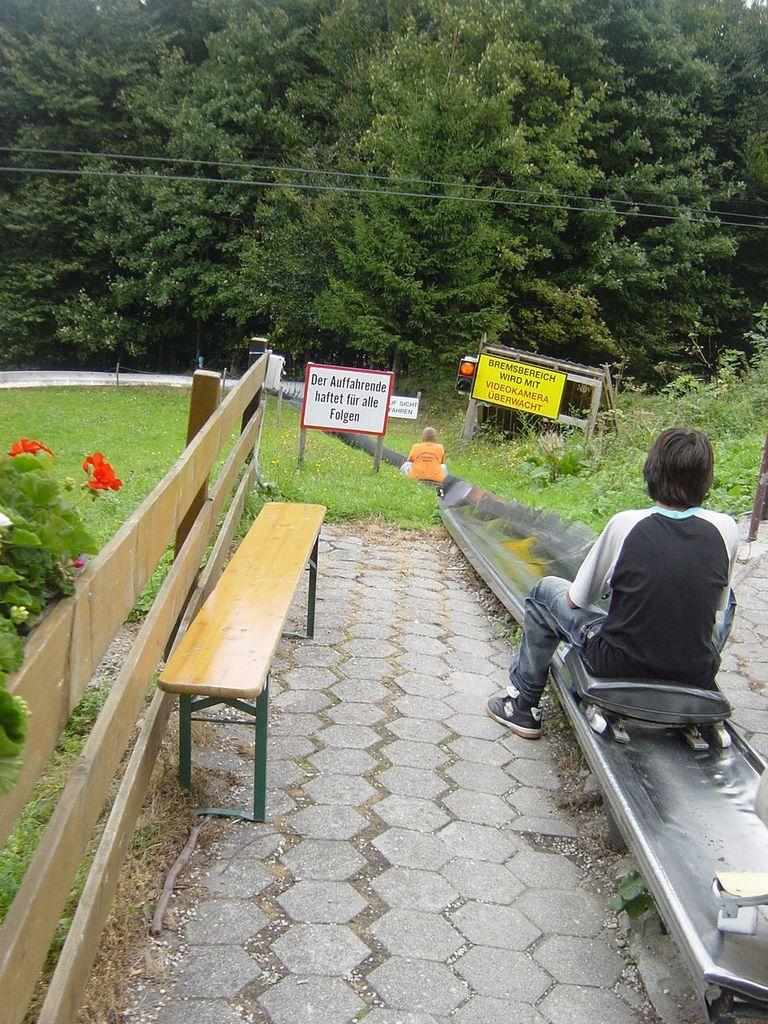Who is the main subject in the image? There is a woman in the image. What is the woman doing in the image? The woman is sitting on a skateboard. What can be seen in the background of the image? There is a bench, plants, grass, boards, and trees in the background of the image. What type of star can be seen shining above the woman in the image? There is no star visible in the image; it is set in an outdoor environment with trees, grass, and other objects. 